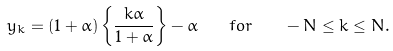<formula> <loc_0><loc_0><loc_500><loc_500>y _ { k } = ( 1 + \alpha ) \left \{ \frac { k \alpha } { 1 + \alpha } \right \} - \alpha \quad f o r \quad - N \leq k \leq N .</formula> 